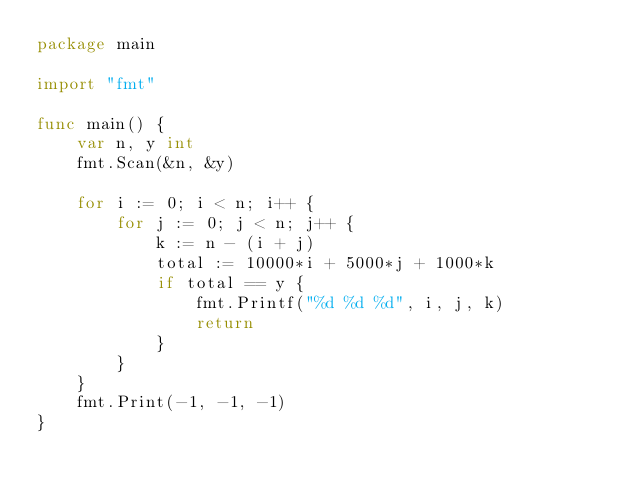<code> <loc_0><loc_0><loc_500><loc_500><_Go_>package main

import "fmt"

func main() {
	var n, y int
	fmt.Scan(&n, &y)

	for i := 0; i < n; i++ {
		for j := 0; j < n; j++ {
			k := n - (i + j)
			total := 10000*i + 5000*j + 1000*k
			if total == y {
				fmt.Printf("%d %d %d", i, j, k)
				return
			}
		}
	}
	fmt.Print(-1, -1, -1)
}
</code> 